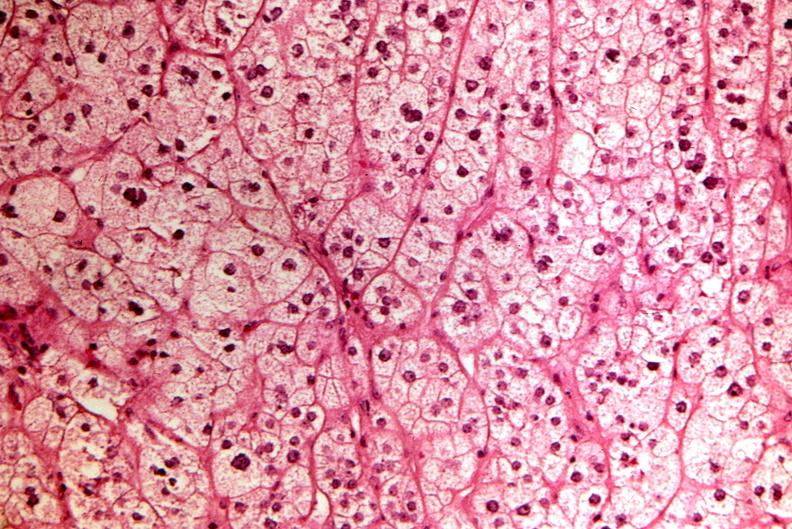s endocrine present?
Answer the question using a single word or phrase. Yes 